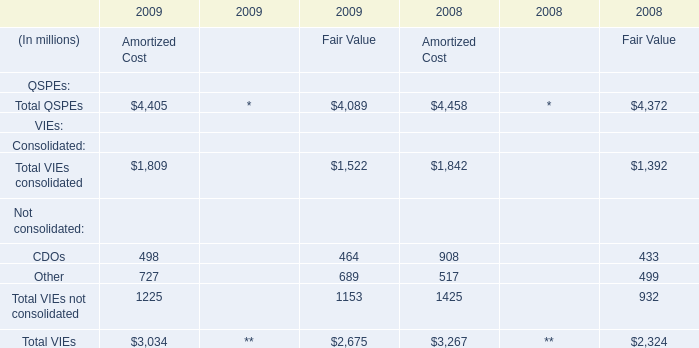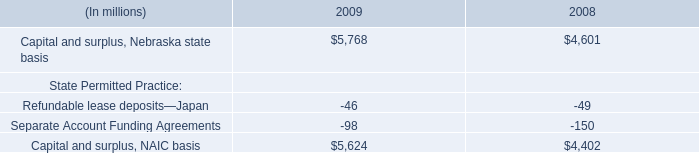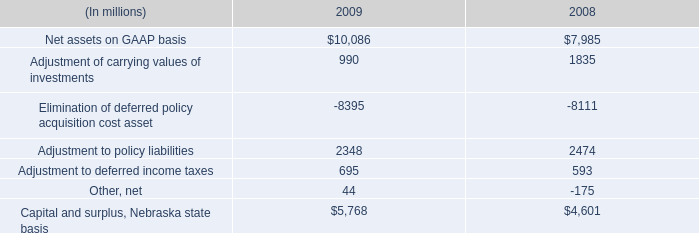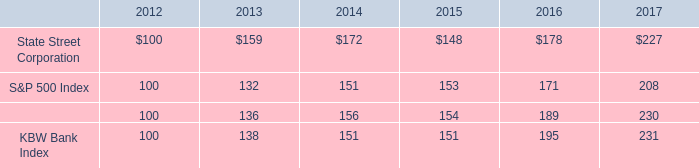What's the average of Amortized Cost in 2008 and 2009? (in milion) 
Computations: (((4405 + 1809) + 1225) + 3034)
Answer: 10473.0. 